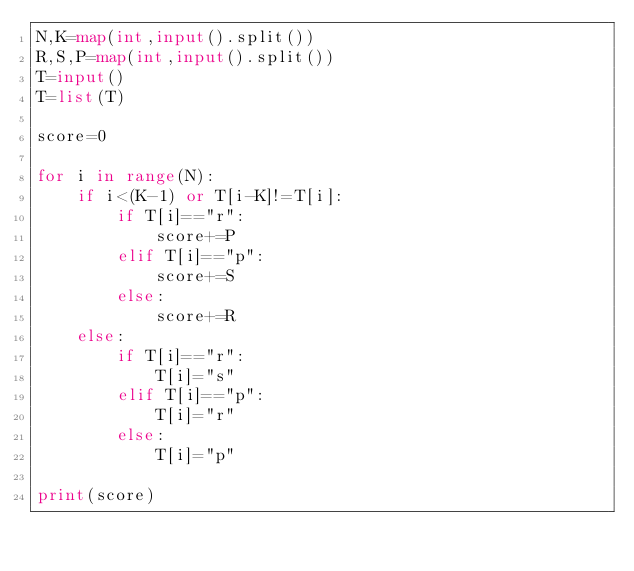<code> <loc_0><loc_0><loc_500><loc_500><_Python_>N,K=map(int,input().split())
R,S,P=map(int,input().split())
T=input()
T=list(T)

score=0

for i in range(N):
    if i<(K-1) or T[i-K]!=T[i]:
        if T[i]=="r":
            score+=P
        elif T[i]=="p":
            score+=S
        else:
            score+=R
    else:
        if T[i]=="r":
            T[i]="s"
        elif T[i]=="p":
            T[i]="r"
        else:
            T[i]="p"

print(score)
    </code> 